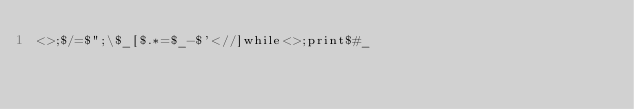<code> <loc_0><loc_0><loc_500><loc_500><_Perl_><>;$/=$";\$_[$.*=$_-$'<//]while<>;print$#_</code> 